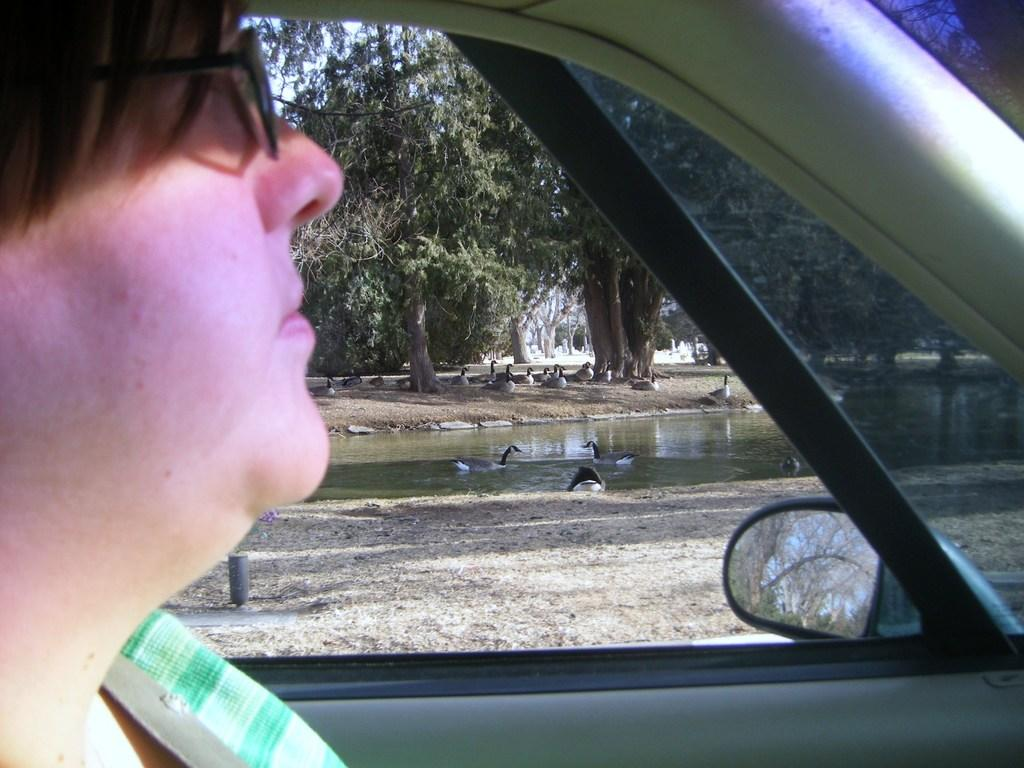What is the person in the image doing? There is a person sitting in a car in the image. What can be seen in the background of the image? There are trees and water visible in the image. What type of bat is hanging from the tree in the image? There is no bat present in the image; only trees and water are visible in the background. 